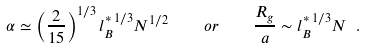Convert formula to latex. <formula><loc_0><loc_0><loc_500><loc_500>\alpha \simeq \left ( \frac { 2 } { 1 5 } \right ) ^ { 1 / 3 } { l } _ { B } ^ { * \, 1 / 3 } N ^ { 1 / 2 } \quad o r \quad \frac { R _ { g } } { a } \sim { l } _ { B } ^ { * \, 1 / 3 } N \ .</formula> 